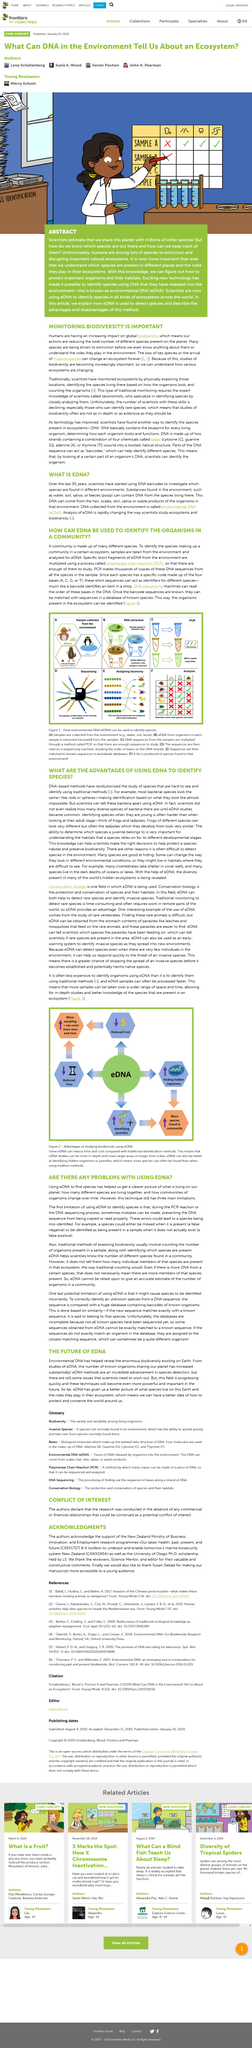Mention a couple of crucial points in this snapshot. The shape of a DNA structure is characterized as twisted and helical. eDNA analysis is an effective and cost-efficient method for identifying organisms in various environments. eDNA fragments are multiplied through the process of Polymerase Chain Reaction (PCR). Conservation biology is the preservation and protection of species and their habitats for future generations. I have determined that DNA has a total of four bases. 